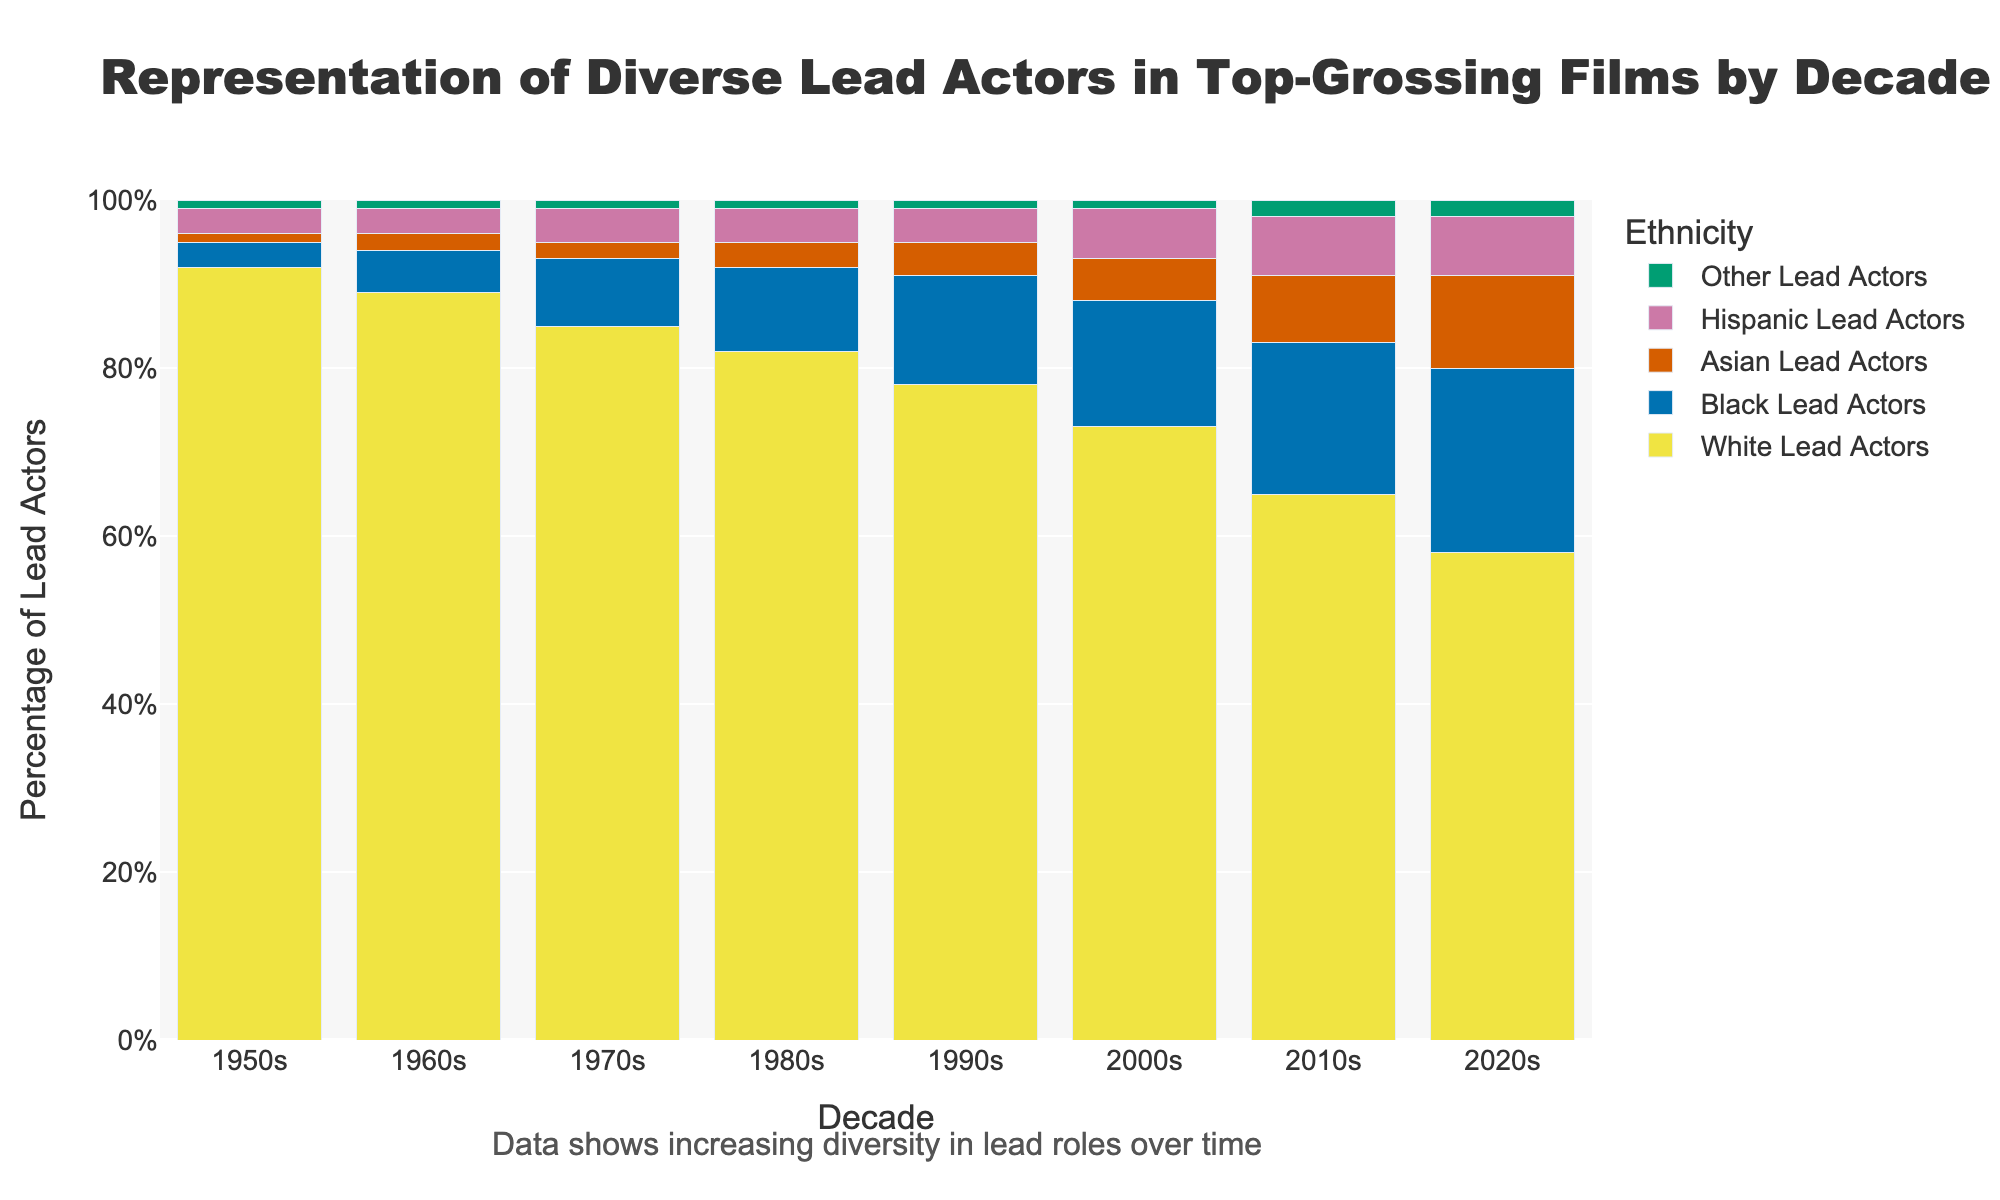How did the representation of Black lead actors change from the 1950s to the 2020s? To determine the change, look at the percentage values for Black Lead Actors for both decades. In the 1950s it was 3%, and in the 2020s, it increased to 22%. The difference is 22% - 3% = 19%.
Answer: 19% Which decade had the highest percentage of Asian lead actors? Compare the percentage values for Asian Lead Actors across all decades shown in the figure. The 2020s had the highest percentage at 11%.
Answer: 2020s How much did the percentage of White lead actors decrease from the 1950s to the 2020s? The percentage of White Lead Actors in the 1950s was 92%, while in the 2020s, it was 58%. The decrease is calculated as 92% - 58% = 34%.
Answer: 34% Compare the percentage of Hispanic lead actors in the 1980s to that in the 2020s. Look at the height of the bars representing Hispanic Lead Actors for both decades. In the 1980s, it was 4%, and in the 2020s, it was 7%. There was an increase, calculated as 7% - 4% = 3%.
Answer: 3% Which ethnicity saw the most substantial increase in representation from the 2010s to the 2020s? Examine the percentage values for all ethnicities in both decades. The percentage of Asian Lead Actors increased from 8% to 11%, a difference of 3%. This is the highest increase among the listed ethnicities.
Answer: Asian Lead Actors Are there any ethnicities where the percentage of lead actors remained the same from the 1950s to the 2020s? Compare the percentage values from the 1950s to the 2020s for each ethnicity. For "Other Lead Actors", the percentage in both decades is 1% and 2% respectively, but technically none remained exactly the same.
Answer: None How does the representation of diverse lead actors collectively change over decades? Sum up the percentage of non-White lead actors for each decade to see the trend. For example, in the 1950s: 3% + 1% + 3% + 1% = 8%. In the 2020s: 22% + 11% + 7% + 2% = 42%. There's a clear increase in diverse representation overall.
Answer: Increased 